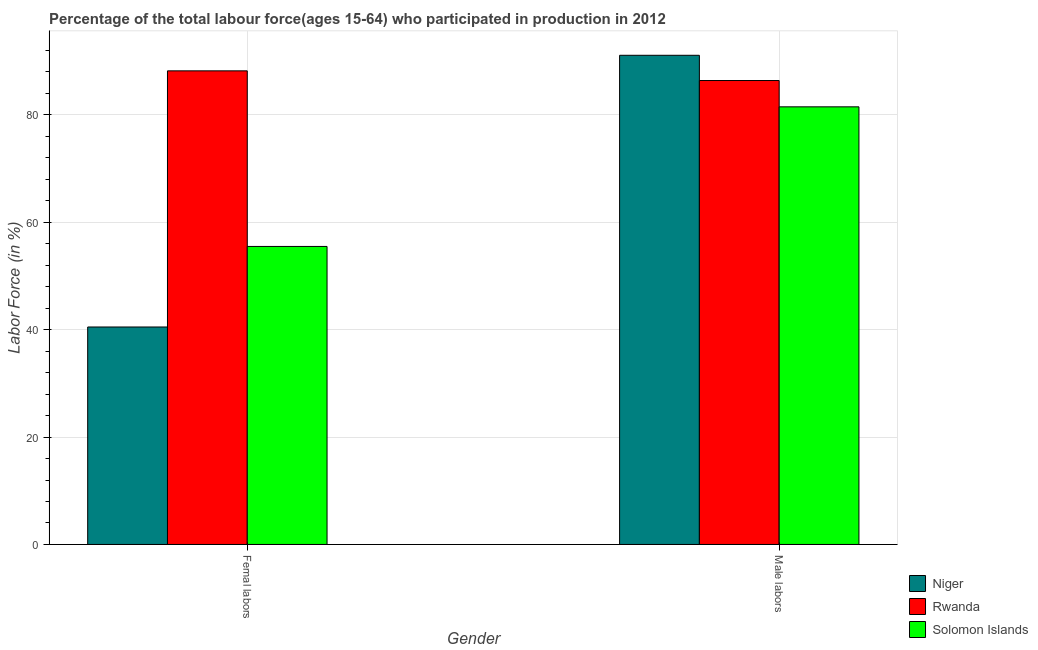How many different coloured bars are there?
Your answer should be very brief. 3. How many groups of bars are there?
Give a very brief answer. 2. How many bars are there on the 2nd tick from the left?
Your answer should be very brief. 3. What is the label of the 2nd group of bars from the left?
Provide a succinct answer. Male labors. What is the percentage of male labour force in Rwanda?
Give a very brief answer. 86.4. Across all countries, what is the maximum percentage of female labor force?
Your response must be concise. 88.2. Across all countries, what is the minimum percentage of female labor force?
Provide a short and direct response. 40.5. In which country was the percentage of female labor force maximum?
Make the answer very short. Rwanda. In which country was the percentage of male labour force minimum?
Keep it short and to the point. Solomon Islands. What is the total percentage of female labor force in the graph?
Provide a short and direct response. 184.2. What is the difference between the percentage of male labour force in Solomon Islands and that in Niger?
Your answer should be very brief. -9.6. What is the difference between the percentage of male labour force in Niger and the percentage of female labor force in Solomon Islands?
Your answer should be compact. 35.6. What is the average percentage of female labor force per country?
Your answer should be very brief. 61.4. What is the difference between the percentage of female labor force and percentage of male labour force in Niger?
Make the answer very short. -50.6. What is the ratio of the percentage of male labour force in Rwanda to that in Niger?
Your answer should be very brief. 0.95. What does the 2nd bar from the left in Male labors represents?
Your response must be concise. Rwanda. What does the 3rd bar from the right in Femal labors represents?
Give a very brief answer. Niger. How many countries are there in the graph?
Provide a succinct answer. 3. What is the difference between two consecutive major ticks on the Y-axis?
Ensure brevity in your answer.  20. Are the values on the major ticks of Y-axis written in scientific E-notation?
Your answer should be compact. No. Does the graph contain grids?
Ensure brevity in your answer.  Yes. How many legend labels are there?
Offer a very short reply. 3. What is the title of the graph?
Offer a terse response. Percentage of the total labour force(ages 15-64) who participated in production in 2012. Does "Israel" appear as one of the legend labels in the graph?
Your answer should be compact. No. What is the label or title of the X-axis?
Your answer should be compact. Gender. What is the Labor Force (in %) in Niger in Femal labors?
Offer a terse response. 40.5. What is the Labor Force (in %) of Rwanda in Femal labors?
Ensure brevity in your answer.  88.2. What is the Labor Force (in %) in Solomon Islands in Femal labors?
Provide a short and direct response. 55.5. What is the Labor Force (in %) of Niger in Male labors?
Your answer should be compact. 91.1. What is the Labor Force (in %) of Rwanda in Male labors?
Offer a terse response. 86.4. What is the Labor Force (in %) in Solomon Islands in Male labors?
Make the answer very short. 81.5. Across all Gender, what is the maximum Labor Force (in %) of Niger?
Give a very brief answer. 91.1. Across all Gender, what is the maximum Labor Force (in %) of Rwanda?
Your answer should be compact. 88.2. Across all Gender, what is the maximum Labor Force (in %) in Solomon Islands?
Provide a short and direct response. 81.5. Across all Gender, what is the minimum Labor Force (in %) of Niger?
Your answer should be very brief. 40.5. Across all Gender, what is the minimum Labor Force (in %) in Rwanda?
Your answer should be very brief. 86.4. Across all Gender, what is the minimum Labor Force (in %) in Solomon Islands?
Ensure brevity in your answer.  55.5. What is the total Labor Force (in %) of Niger in the graph?
Provide a succinct answer. 131.6. What is the total Labor Force (in %) in Rwanda in the graph?
Your response must be concise. 174.6. What is the total Labor Force (in %) in Solomon Islands in the graph?
Your response must be concise. 137. What is the difference between the Labor Force (in %) of Niger in Femal labors and that in Male labors?
Your response must be concise. -50.6. What is the difference between the Labor Force (in %) of Solomon Islands in Femal labors and that in Male labors?
Ensure brevity in your answer.  -26. What is the difference between the Labor Force (in %) of Niger in Femal labors and the Labor Force (in %) of Rwanda in Male labors?
Your answer should be very brief. -45.9. What is the difference between the Labor Force (in %) of Niger in Femal labors and the Labor Force (in %) of Solomon Islands in Male labors?
Keep it short and to the point. -41. What is the difference between the Labor Force (in %) of Rwanda in Femal labors and the Labor Force (in %) of Solomon Islands in Male labors?
Give a very brief answer. 6.7. What is the average Labor Force (in %) in Niger per Gender?
Ensure brevity in your answer.  65.8. What is the average Labor Force (in %) of Rwanda per Gender?
Make the answer very short. 87.3. What is the average Labor Force (in %) in Solomon Islands per Gender?
Provide a short and direct response. 68.5. What is the difference between the Labor Force (in %) of Niger and Labor Force (in %) of Rwanda in Femal labors?
Your answer should be very brief. -47.7. What is the difference between the Labor Force (in %) of Rwanda and Labor Force (in %) of Solomon Islands in Femal labors?
Offer a terse response. 32.7. What is the difference between the Labor Force (in %) of Niger and Labor Force (in %) of Rwanda in Male labors?
Provide a succinct answer. 4.7. What is the difference between the Labor Force (in %) of Rwanda and Labor Force (in %) of Solomon Islands in Male labors?
Offer a terse response. 4.9. What is the ratio of the Labor Force (in %) of Niger in Femal labors to that in Male labors?
Provide a short and direct response. 0.44. What is the ratio of the Labor Force (in %) in Rwanda in Femal labors to that in Male labors?
Offer a terse response. 1.02. What is the ratio of the Labor Force (in %) of Solomon Islands in Femal labors to that in Male labors?
Your answer should be compact. 0.68. What is the difference between the highest and the second highest Labor Force (in %) in Niger?
Your answer should be very brief. 50.6. What is the difference between the highest and the second highest Labor Force (in %) in Solomon Islands?
Make the answer very short. 26. What is the difference between the highest and the lowest Labor Force (in %) of Niger?
Give a very brief answer. 50.6. What is the difference between the highest and the lowest Labor Force (in %) of Solomon Islands?
Offer a very short reply. 26. 